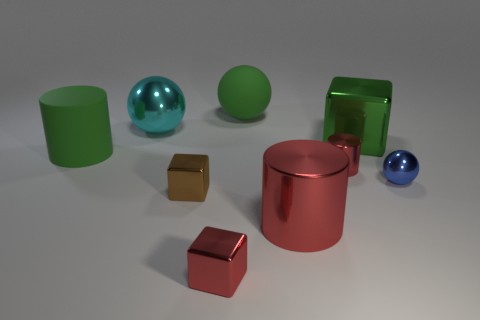There is a ball that is the same color as the large metallic cube; what material is it?
Your response must be concise. Rubber. Are there any other things that are the same shape as the blue metallic object?
Your response must be concise. Yes. There is a large rubber thing left of the large sphere that is to the right of the metallic cube that is left of the small red block; what is its color?
Keep it short and to the point. Green. What number of big objects are either red cubes or green cylinders?
Offer a very short reply. 1. Are there an equal number of blue metallic spheres behind the large red object and small blue blocks?
Keep it short and to the point. No. There is a red cube; are there any metallic cylinders behind it?
Your answer should be compact. Yes. How many shiny objects are either small red cylinders or blue objects?
Your answer should be very brief. 2. How many large green rubber objects are in front of the green ball?
Offer a terse response. 1. Are there any spheres that have the same size as the blue object?
Offer a very short reply. No. Are there any big metal objects that have the same color as the matte cylinder?
Offer a very short reply. Yes. 